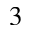Convert formula to latex. <formula><loc_0><loc_0><loc_500><loc_500>_ { 3 }</formula> 